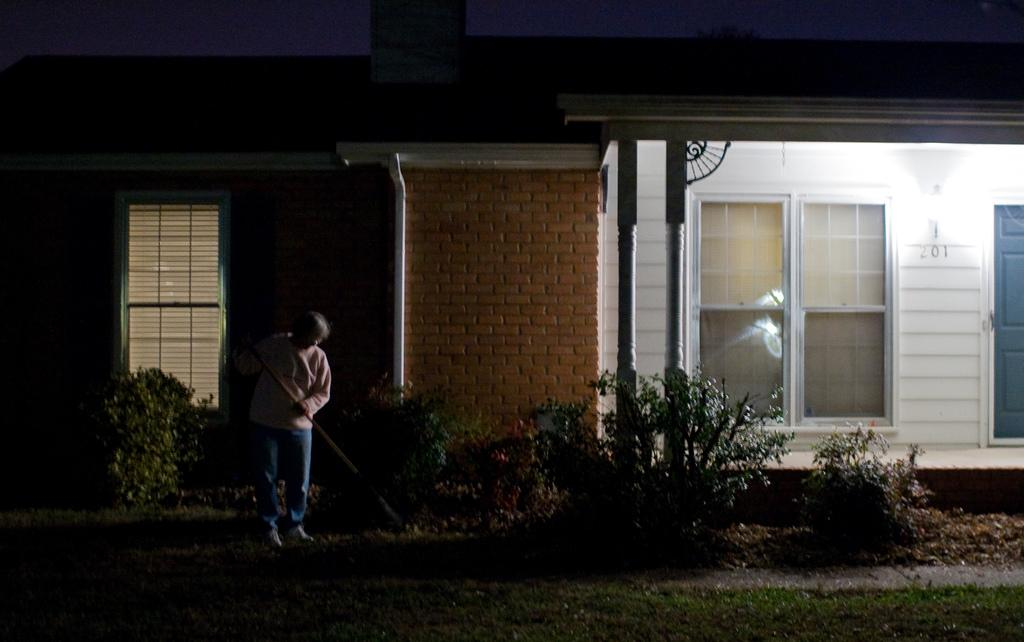Who or what is present in the image? There is a person in the image. What type of vegetation can be seen in the image? There are plants and grass in the image. What can be seen through the window in the image? The window in the image provides a view of the background, which includes a building. What type of match is being played in the image? There is no match or game being played in the image; it features a person, plants, grass, a window, and a building in the background. 